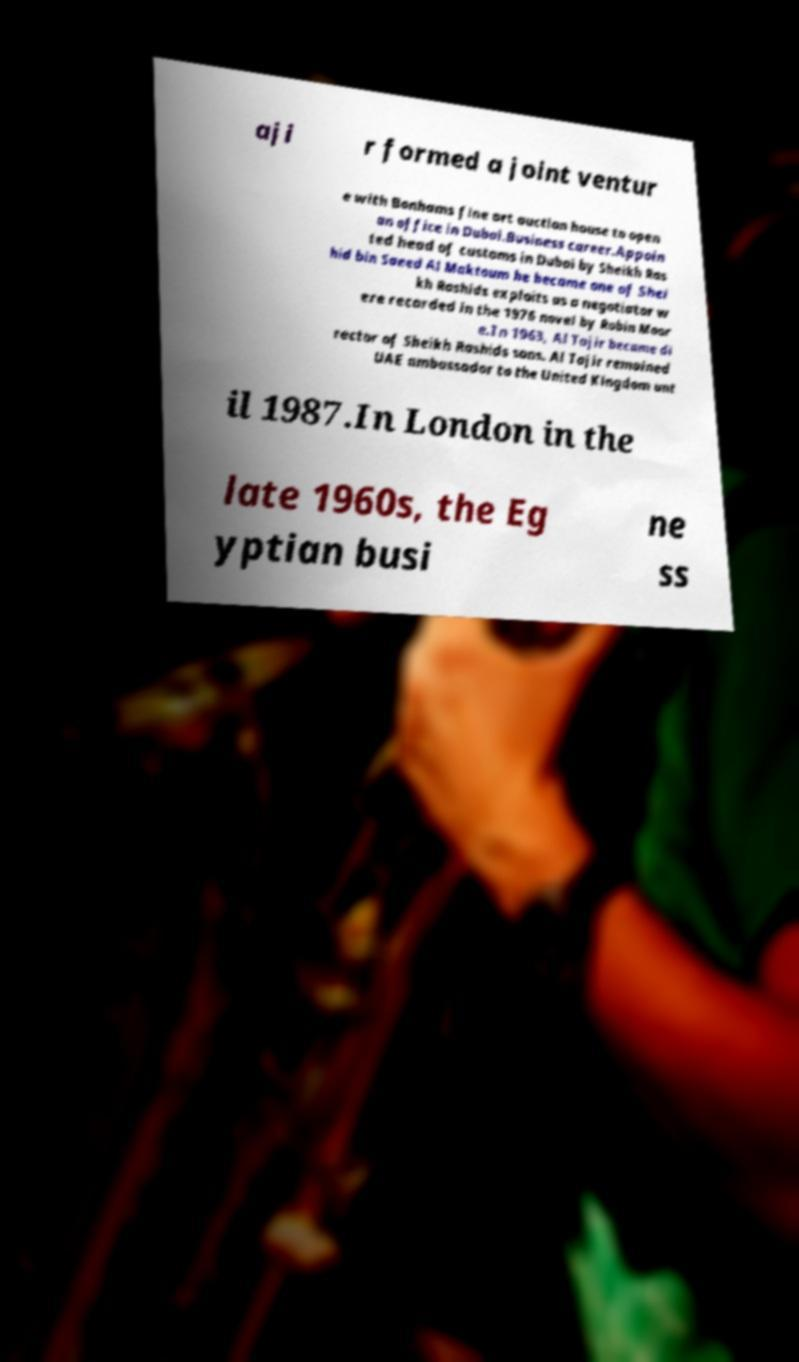Can you read and provide the text displayed in the image?This photo seems to have some interesting text. Can you extract and type it out for me? aji r formed a joint ventur e with Bonhams fine art auction house to open an office in Dubai.Business career.Appoin ted head of customs in Dubai by Sheikh Ras hid bin Saeed Al Maktoum he became one of Shei kh Rashids exploits as a negotiator w ere recorded in the 1976 novel by Robin Moor e.In 1963, Al Tajir became di rector of Sheikh Rashids sons. Al Tajir remained UAE ambassador to the United Kingdom unt il 1987.In London in the late 1960s, the Eg yptian busi ne ss 